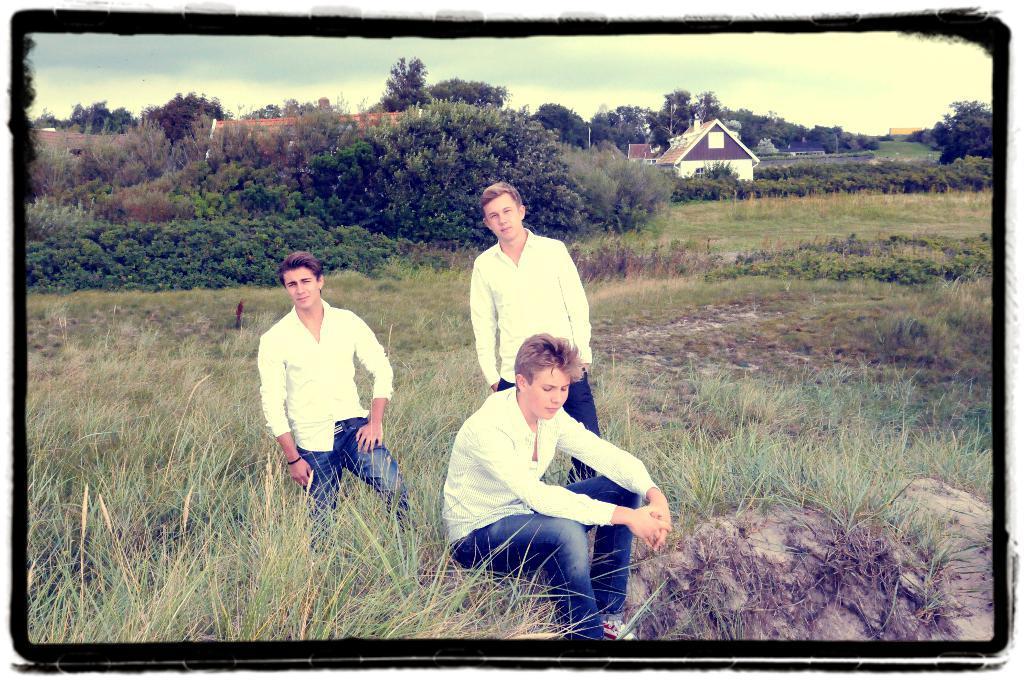Describe this image in one or two sentences. This is an edited image, where there are three persons, a person sitting on the rock, two persons standing, plants, grass, houses, trees, poles, and in the background there is sky. 